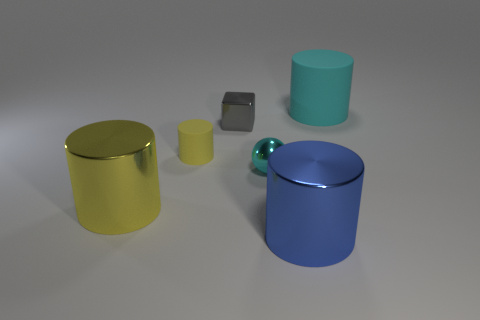Does the big blue metal thing have the same shape as the big cyan rubber object?
Make the answer very short. Yes. How many rubber cylinders are on the right side of the large blue metal object and on the left side of the large blue shiny thing?
Provide a short and direct response. 0. Are there an equal number of small yellow objects in front of the small ball and shiny things that are in front of the big yellow thing?
Provide a succinct answer. No. There is a matte object in front of the tiny gray metallic block; is its size the same as the metal cylinder in front of the big yellow cylinder?
Ensure brevity in your answer.  No. There is a big cylinder that is behind the big blue metal cylinder and to the right of the tiny gray block; what is its material?
Provide a succinct answer. Rubber. Is the number of tiny cyan spheres less than the number of big objects?
Provide a short and direct response. Yes. What size is the cyan thing that is in front of the cylinder that is behind the tiny yellow object?
Offer a very short reply. Small. What shape is the small metallic object that is behind the cyan thing that is in front of the cyan object that is on the right side of the blue metal object?
Provide a succinct answer. Cube. What is the color of the tiny object that is made of the same material as the small cube?
Offer a very short reply. Cyan. What color is the big thing that is on the left side of the matte cylinder in front of the big cylinder that is behind the small yellow cylinder?
Offer a very short reply. Yellow. 